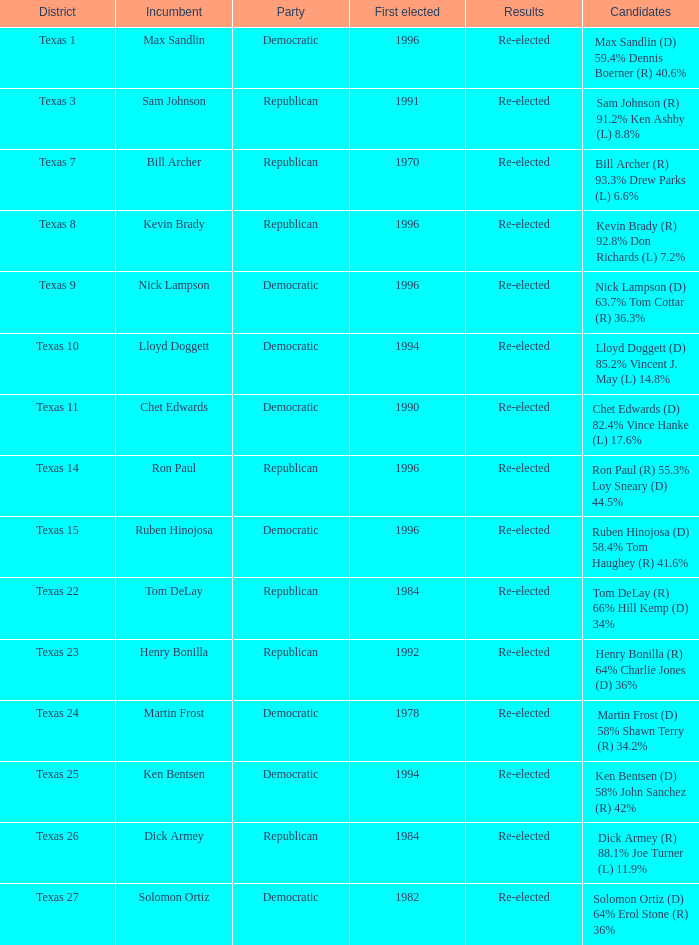Ruben hinojosa represents which district? Texas 15. 